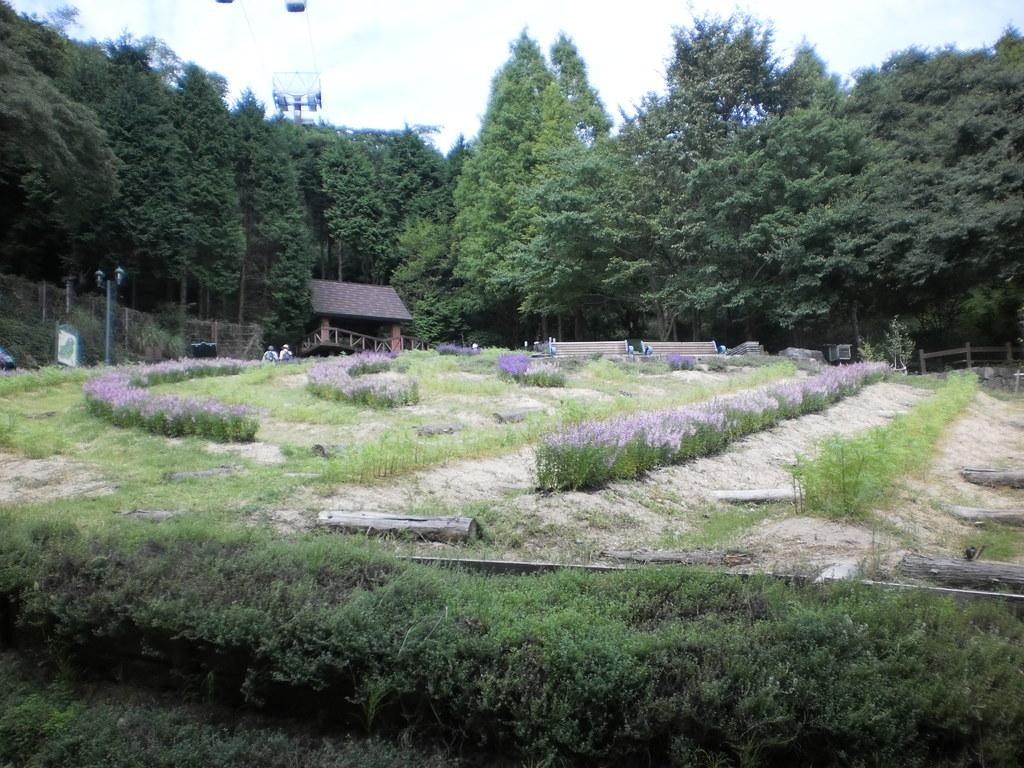What type of vegetation can be seen in the image? There are trees in the image. What type of structure is present in the image? There is a house in the image. What is the purpose of the light-pole in the image? The light-pole provides illumination in the image. What type of seating is available in the image? There is a bench in the image. How many people are in the image? There are two people in the image. What is the color of the sky in the image? The sky appears to be white in color. What type of material is used for the wooden logs in the image? The wooden logs are made of wood. What type of barrier is present in the image? There is fencing in the image. Where is the baby located in the image? There is no baby present in the image. What type of patch is sewn onto the wooden logs in the image? There are no patches on the wooden logs in the image; they are made of wood. 